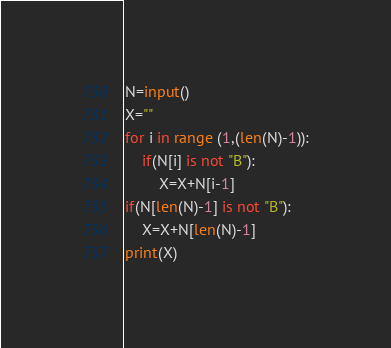Convert code to text. <code><loc_0><loc_0><loc_500><loc_500><_Python_>N=input()
X=""
for i in range (1,(len(N)-1)):
    if(N[i] is not "B"):
        X=X+N[i-1]
if(N[len(N)-1] is not "B"):
    X=X+N[len(N)-1]
print(X)
</code> 